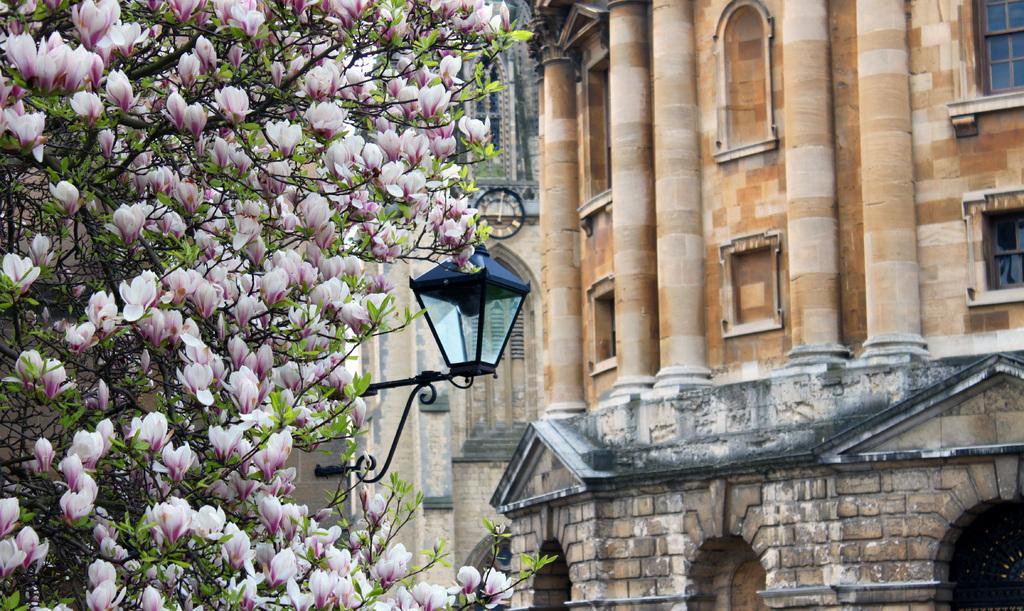Describe this image in one or two sentences. There are flowers to a tree and a lamp in the foreground area of the image and buildings in the background. 